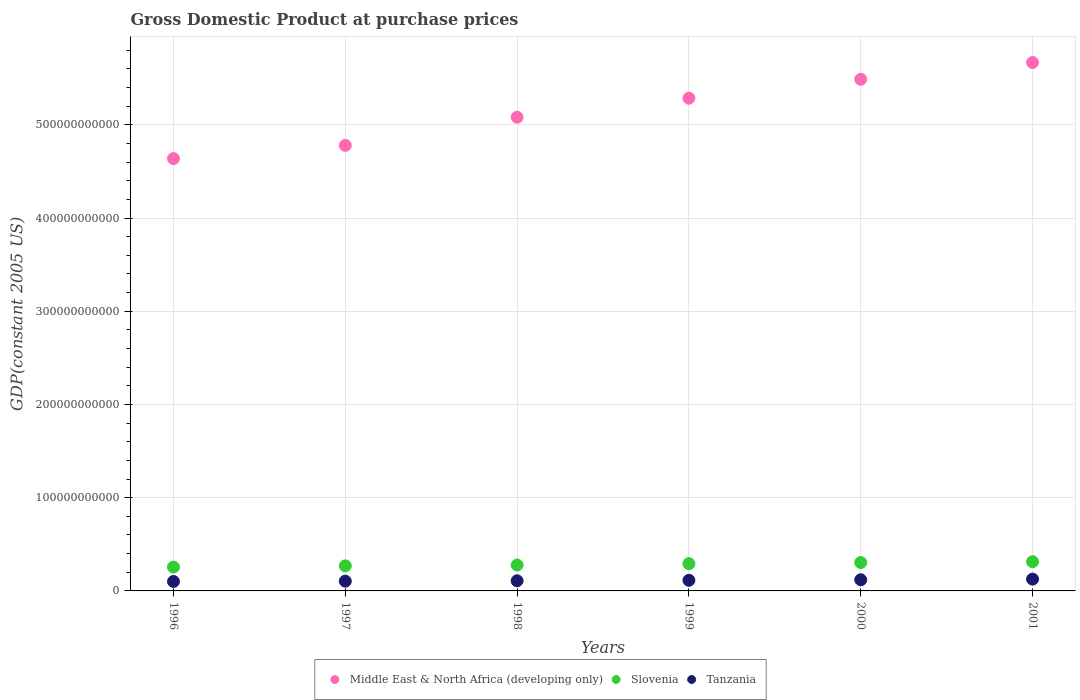How many different coloured dotlines are there?
Keep it short and to the point. 3. Is the number of dotlines equal to the number of legend labels?
Provide a short and direct response. Yes. What is the GDP at purchase prices in Middle East & North Africa (developing only) in 1998?
Your answer should be very brief. 5.08e+11. Across all years, what is the maximum GDP at purchase prices in Slovenia?
Provide a succinct answer. 3.14e+1. Across all years, what is the minimum GDP at purchase prices in Slovenia?
Make the answer very short. 2.56e+1. In which year was the GDP at purchase prices in Tanzania minimum?
Your answer should be very brief. 1996. What is the total GDP at purchase prices in Middle East & North Africa (developing only) in the graph?
Provide a succinct answer. 3.09e+12. What is the difference between the GDP at purchase prices in Slovenia in 1999 and that in 2000?
Provide a succinct answer. -1.22e+09. What is the difference between the GDP at purchase prices in Slovenia in 1997 and the GDP at purchase prices in Tanzania in 2000?
Your response must be concise. 1.49e+1. What is the average GDP at purchase prices in Tanzania per year?
Your response must be concise. 1.12e+1. In the year 2001, what is the difference between the GDP at purchase prices in Slovenia and GDP at purchase prices in Middle East & North Africa (developing only)?
Offer a terse response. -5.36e+11. In how many years, is the GDP at purchase prices in Tanzania greater than 300000000000 US$?
Ensure brevity in your answer.  0. What is the ratio of the GDP at purchase prices in Middle East & North Africa (developing only) in 1996 to that in 1999?
Offer a very short reply. 0.88. Is the GDP at purchase prices in Middle East & North Africa (developing only) in 1996 less than that in 2001?
Give a very brief answer. Yes. What is the difference between the highest and the second highest GDP at purchase prices in Slovenia?
Provide a succinct answer. 8.98e+08. What is the difference between the highest and the lowest GDP at purchase prices in Slovenia?
Your answer should be very brief. 5.77e+09. In how many years, is the GDP at purchase prices in Tanzania greater than the average GDP at purchase prices in Tanzania taken over all years?
Provide a succinct answer. 3. Is the sum of the GDP at purchase prices in Middle East & North Africa (developing only) in 1998 and 1999 greater than the maximum GDP at purchase prices in Slovenia across all years?
Offer a terse response. Yes. Is it the case that in every year, the sum of the GDP at purchase prices in Tanzania and GDP at purchase prices in Slovenia  is greater than the GDP at purchase prices in Middle East & North Africa (developing only)?
Provide a short and direct response. No. Is the GDP at purchase prices in Slovenia strictly greater than the GDP at purchase prices in Middle East & North Africa (developing only) over the years?
Your answer should be compact. No. How many dotlines are there?
Offer a terse response. 3. What is the difference between two consecutive major ticks on the Y-axis?
Keep it short and to the point. 1.00e+11. Does the graph contain any zero values?
Provide a succinct answer. No. Where does the legend appear in the graph?
Ensure brevity in your answer.  Bottom center. How many legend labels are there?
Your answer should be compact. 3. How are the legend labels stacked?
Your answer should be compact. Horizontal. What is the title of the graph?
Provide a short and direct response. Gross Domestic Product at purchase prices. What is the label or title of the Y-axis?
Offer a very short reply. GDP(constant 2005 US). What is the GDP(constant 2005 US) of Middle East & North Africa (developing only) in 1996?
Make the answer very short. 4.64e+11. What is the GDP(constant 2005 US) of Slovenia in 1996?
Make the answer very short. 2.56e+1. What is the GDP(constant 2005 US) of Tanzania in 1996?
Make the answer very short. 1.01e+1. What is the GDP(constant 2005 US) in Middle East & North Africa (developing only) in 1997?
Your response must be concise. 4.78e+11. What is the GDP(constant 2005 US) in Slovenia in 1997?
Provide a succinct answer. 2.69e+1. What is the GDP(constant 2005 US) in Tanzania in 1997?
Make the answer very short. 1.05e+1. What is the GDP(constant 2005 US) in Middle East & North Africa (developing only) in 1998?
Offer a terse response. 5.08e+11. What is the GDP(constant 2005 US) of Slovenia in 1998?
Ensure brevity in your answer.  2.78e+1. What is the GDP(constant 2005 US) of Tanzania in 1998?
Your response must be concise. 1.09e+1. What is the GDP(constant 2005 US) of Middle East & North Africa (developing only) in 1999?
Ensure brevity in your answer.  5.29e+11. What is the GDP(constant 2005 US) in Slovenia in 1999?
Ensure brevity in your answer.  2.92e+1. What is the GDP(constant 2005 US) in Tanzania in 1999?
Offer a terse response. 1.14e+1. What is the GDP(constant 2005 US) in Middle East & North Africa (developing only) in 2000?
Provide a short and direct response. 5.49e+11. What is the GDP(constant 2005 US) of Slovenia in 2000?
Provide a short and direct response. 3.05e+1. What is the GDP(constant 2005 US) in Tanzania in 2000?
Your response must be concise. 1.20e+1. What is the GDP(constant 2005 US) in Middle East & North Africa (developing only) in 2001?
Your answer should be very brief. 5.67e+11. What is the GDP(constant 2005 US) of Slovenia in 2001?
Offer a very short reply. 3.14e+1. What is the GDP(constant 2005 US) of Tanzania in 2001?
Give a very brief answer. 1.27e+1. Across all years, what is the maximum GDP(constant 2005 US) of Middle East & North Africa (developing only)?
Ensure brevity in your answer.  5.67e+11. Across all years, what is the maximum GDP(constant 2005 US) of Slovenia?
Offer a very short reply. 3.14e+1. Across all years, what is the maximum GDP(constant 2005 US) in Tanzania?
Offer a terse response. 1.27e+1. Across all years, what is the minimum GDP(constant 2005 US) in Middle East & North Africa (developing only)?
Your response must be concise. 4.64e+11. Across all years, what is the minimum GDP(constant 2005 US) of Slovenia?
Provide a short and direct response. 2.56e+1. Across all years, what is the minimum GDP(constant 2005 US) of Tanzania?
Keep it short and to the point. 1.01e+1. What is the total GDP(constant 2005 US) in Middle East & North Africa (developing only) in the graph?
Ensure brevity in your answer.  3.09e+12. What is the total GDP(constant 2005 US) in Slovenia in the graph?
Offer a terse response. 1.71e+11. What is the total GDP(constant 2005 US) of Tanzania in the graph?
Provide a short and direct response. 6.75e+1. What is the difference between the GDP(constant 2005 US) of Middle East & North Africa (developing only) in 1996 and that in 1997?
Offer a terse response. -1.42e+1. What is the difference between the GDP(constant 2005 US) of Slovenia in 1996 and that in 1997?
Ensure brevity in your answer.  -1.31e+09. What is the difference between the GDP(constant 2005 US) of Tanzania in 1996 and that in 1997?
Your answer should be very brief. -3.57e+08. What is the difference between the GDP(constant 2005 US) of Middle East & North Africa (developing only) in 1996 and that in 1998?
Your response must be concise. -4.43e+1. What is the difference between the GDP(constant 2005 US) of Slovenia in 1996 and that in 1998?
Give a very brief answer. -2.19e+09. What is the difference between the GDP(constant 2005 US) in Tanzania in 1996 and that in 1998?
Provide a short and direct response. -7.45e+08. What is the difference between the GDP(constant 2005 US) in Middle East & North Africa (developing only) in 1996 and that in 1999?
Offer a terse response. -6.48e+1. What is the difference between the GDP(constant 2005 US) in Slovenia in 1996 and that in 1999?
Your answer should be very brief. -3.66e+09. What is the difference between the GDP(constant 2005 US) in Tanzania in 1996 and that in 1999?
Make the answer very short. -1.27e+09. What is the difference between the GDP(constant 2005 US) of Middle East & North Africa (developing only) in 1996 and that in 2000?
Ensure brevity in your answer.  -8.51e+1. What is the difference between the GDP(constant 2005 US) in Slovenia in 1996 and that in 2000?
Offer a very short reply. -4.87e+09. What is the difference between the GDP(constant 2005 US) in Tanzania in 1996 and that in 2000?
Your answer should be very brief. -1.83e+09. What is the difference between the GDP(constant 2005 US) of Middle East & North Africa (developing only) in 1996 and that in 2001?
Provide a succinct answer. -1.03e+11. What is the difference between the GDP(constant 2005 US) in Slovenia in 1996 and that in 2001?
Offer a very short reply. -5.77e+09. What is the difference between the GDP(constant 2005 US) in Tanzania in 1996 and that in 2001?
Offer a very short reply. -2.55e+09. What is the difference between the GDP(constant 2005 US) of Middle East & North Africa (developing only) in 1997 and that in 1998?
Keep it short and to the point. -3.02e+1. What is the difference between the GDP(constant 2005 US) of Slovenia in 1997 and that in 1998?
Keep it short and to the point. -8.84e+08. What is the difference between the GDP(constant 2005 US) in Tanzania in 1997 and that in 1998?
Provide a succinct answer. -3.89e+08. What is the difference between the GDP(constant 2005 US) of Middle East & North Africa (developing only) in 1997 and that in 1999?
Provide a short and direct response. -5.06e+1. What is the difference between the GDP(constant 2005 US) in Slovenia in 1997 and that in 1999?
Keep it short and to the point. -2.35e+09. What is the difference between the GDP(constant 2005 US) of Tanzania in 1997 and that in 1999?
Provide a short and direct response. -9.15e+08. What is the difference between the GDP(constant 2005 US) in Middle East & North Africa (developing only) in 1997 and that in 2000?
Give a very brief answer. -7.09e+1. What is the difference between the GDP(constant 2005 US) of Slovenia in 1997 and that in 2000?
Provide a short and direct response. -3.56e+09. What is the difference between the GDP(constant 2005 US) in Tanzania in 1997 and that in 2000?
Your response must be concise. -1.48e+09. What is the difference between the GDP(constant 2005 US) of Middle East & North Africa (developing only) in 1997 and that in 2001?
Ensure brevity in your answer.  -8.89e+1. What is the difference between the GDP(constant 2005 US) of Slovenia in 1997 and that in 2001?
Ensure brevity in your answer.  -4.46e+09. What is the difference between the GDP(constant 2005 US) of Tanzania in 1997 and that in 2001?
Keep it short and to the point. -2.19e+09. What is the difference between the GDP(constant 2005 US) of Middle East & North Africa (developing only) in 1998 and that in 1999?
Make the answer very short. -2.04e+1. What is the difference between the GDP(constant 2005 US) in Slovenia in 1998 and that in 1999?
Offer a terse response. -1.47e+09. What is the difference between the GDP(constant 2005 US) of Tanzania in 1998 and that in 1999?
Offer a terse response. -5.26e+08. What is the difference between the GDP(constant 2005 US) of Middle East & North Africa (developing only) in 1998 and that in 2000?
Give a very brief answer. -4.07e+1. What is the difference between the GDP(constant 2005 US) in Slovenia in 1998 and that in 2000?
Offer a very short reply. -2.68e+09. What is the difference between the GDP(constant 2005 US) of Tanzania in 1998 and that in 2000?
Offer a terse response. -1.09e+09. What is the difference between the GDP(constant 2005 US) in Middle East & North Africa (developing only) in 1998 and that in 2001?
Make the answer very short. -5.87e+1. What is the difference between the GDP(constant 2005 US) in Slovenia in 1998 and that in 2001?
Your answer should be very brief. -3.58e+09. What is the difference between the GDP(constant 2005 US) in Tanzania in 1998 and that in 2001?
Your answer should be compact. -1.81e+09. What is the difference between the GDP(constant 2005 US) of Middle East & North Africa (developing only) in 1999 and that in 2000?
Keep it short and to the point. -2.03e+1. What is the difference between the GDP(constant 2005 US) in Slovenia in 1999 and that in 2000?
Your response must be concise. -1.22e+09. What is the difference between the GDP(constant 2005 US) in Tanzania in 1999 and that in 2000?
Ensure brevity in your answer.  -5.62e+08. What is the difference between the GDP(constant 2005 US) in Middle East & North Africa (developing only) in 1999 and that in 2001?
Keep it short and to the point. -3.83e+1. What is the difference between the GDP(constant 2005 US) in Slovenia in 1999 and that in 2001?
Your answer should be very brief. -2.11e+09. What is the difference between the GDP(constant 2005 US) in Tanzania in 1999 and that in 2001?
Your answer should be very brief. -1.28e+09. What is the difference between the GDP(constant 2005 US) of Middle East & North Africa (developing only) in 2000 and that in 2001?
Offer a terse response. -1.80e+1. What is the difference between the GDP(constant 2005 US) in Slovenia in 2000 and that in 2001?
Keep it short and to the point. -8.98e+08. What is the difference between the GDP(constant 2005 US) in Tanzania in 2000 and that in 2001?
Provide a succinct answer. -7.17e+08. What is the difference between the GDP(constant 2005 US) in Middle East & North Africa (developing only) in 1996 and the GDP(constant 2005 US) in Slovenia in 1997?
Give a very brief answer. 4.37e+11. What is the difference between the GDP(constant 2005 US) of Middle East & North Africa (developing only) in 1996 and the GDP(constant 2005 US) of Tanzania in 1997?
Your response must be concise. 4.53e+11. What is the difference between the GDP(constant 2005 US) of Slovenia in 1996 and the GDP(constant 2005 US) of Tanzania in 1997?
Your answer should be very brief. 1.51e+1. What is the difference between the GDP(constant 2005 US) of Middle East & North Africa (developing only) in 1996 and the GDP(constant 2005 US) of Slovenia in 1998?
Ensure brevity in your answer.  4.36e+11. What is the difference between the GDP(constant 2005 US) in Middle East & North Africa (developing only) in 1996 and the GDP(constant 2005 US) in Tanzania in 1998?
Provide a short and direct response. 4.53e+11. What is the difference between the GDP(constant 2005 US) in Slovenia in 1996 and the GDP(constant 2005 US) in Tanzania in 1998?
Your response must be concise. 1.47e+1. What is the difference between the GDP(constant 2005 US) in Middle East & North Africa (developing only) in 1996 and the GDP(constant 2005 US) in Slovenia in 1999?
Provide a succinct answer. 4.35e+11. What is the difference between the GDP(constant 2005 US) of Middle East & North Africa (developing only) in 1996 and the GDP(constant 2005 US) of Tanzania in 1999?
Offer a terse response. 4.52e+11. What is the difference between the GDP(constant 2005 US) in Slovenia in 1996 and the GDP(constant 2005 US) in Tanzania in 1999?
Offer a very short reply. 1.42e+1. What is the difference between the GDP(constant 2005 US) in Middle East & North Africa (developing only) in 1996 and the GDP(constant 2005 US) in Slovenia in 2000?
Make the answer very short. 4.33e+11. What is the difference between the GDP(constant 2005 US) of Middle East & North Africa (developing only) in 1996 and the GDP(constant 2005 US) of Tanzania in 2000?
Offer a very short reply. 4.52e+11. What is the difference between the GDP(constant 2005 US) of Slovenia in 1996 and the GDP(constant 2005 US) of Tanzania in 2000?
Provide a short and direct response. 1.36e+1. What is the difference between the GDP(constant 2005 US) in Middle East & North Africa (developing only) in 1996 and the GDP(constant 2005 US) in Slovenia in 2001?
Keep it short and to the point. 4.32e+11. What is the difference between the GDP(constant 2005 US) of Middle East & North Africa (developing only) in 1996 and the GDP(constant 2005 US) of Tanzania in 2001?
Ensure brevity in your answer.  4.51e+11. What is the difference between the GDP(constant 2005 US) in Slovenia in 1996 and the GDP(constant 2005 US) in Tanzania in 2001?
Make the answer very short. 1.29e+1. What is the difference between the GDP(constant 2005 US) of Middle East & North Africa (developing only) in 1997 and the GDP(constant 2005 US) of Slovenia in 1998?
Give a very brief answer. 4.50e+11. What is the difference between the GDP(constant 2005 US) of Middle East & North Africa (developing only) in 1997 and the GDP(constant 2005 US) of Tanzania in 1998?
Offer a terse response. 4.67e+11. What is the difference between the GDP(constant 2005 US) of Slovenia in 1997 and the GDP(constant 2005 US) of Tanzania in 1998?
Keep it short and to the point. 1.60e+1. What is the difference between the GDP(constant 2005 US) in Middle East & North Africa (developing only) in 1997 and the GDP(constant 2005 US) in Slovenia in 1999?
Offer a very short reply. 4.49e+11. What is the difference between the GDP(constant 2005 US) in Middle East & North Africa (developing only) in 1997 and the GDP(constant 2005 US) in Tanzania in 1999?
Your answer should be compact. 4.67e+11. What is the difference between the GDP(constant 2005 US) in Slovenia in 1997 and the GDP(constant 2005 US) in Tanzania in 1999?
Provide a succinct answer. 1.55e+1. What is the difference between the GDP(constant 2005 US) in Middle East & North Africa (developing only) in 1997 and the GDP(constant 2005 US) in Slovenia in 2000?
Your answer should be compact. 4.48e+11. What is the difference between the GDP(constant 2005 US) in Middle East & North Africa (developing only) in 1997 and the GDP(constant 2005 US) in Tanzania in 2000?
Provide a succinct answer. 4.66e+11. What is the difference between the GDP(constant 2005 US) of Slovenia in 1997 and the GDP(constant 2005 US) of Tanzania in 2000?
Keep it short and to the point. 1.49e+1. What is the difference between the GDP(constant 2005 US) of Middle East & North Africa (developing only) in 1997 and the GDP(constant 2005 US) of Slovenia in 2001?
Your answer should be compact. 4.47e+11. What is the difference between the GDP(constant 2005 US) in Middle East & North Africa (developing only) in 1997 and the GDP(constant 2005 US) in Tanzania in 2001?
Give a very brief answer. 4.65e+11. What is the difference between the GDP(constant 2005 US) in Slovenia in 1997 and the GDP(constant 2005 US) in Tanzania in 2001?
Your answer should be very brief. 1.42e+1. What is the difference between the GDP(constant 2005 US) in Middle East & North Africa (developing only) in 1998 and the GDP(constant 2005 US) in Slovenia in 1999?
Make the answer very short. 4.79e+11. What is the difference between the GDP(constant 2005 US) of Middle East & North Africa (developing only) in 1998 and the GDP(constant 2005 US) of Tanzania in 1999?
Your answer should be very brief. 4.97e+11. What is the difference between the GDP(constant 2005 US) in Slovenia in 1998 and the GDP(constant 2005 US) in Tanzania in 1999?
Offer a very short reply. 1.64e+1. What is the difference between the GDP(constant 2005 US) of Middle East & North Africa (developing only) in 1998 and the GDP(constant 2005 US) of Slovenia in 2000?
Provide a short and direct response. 4.78e+11. What is the difference between the GDP(constant 2005 US) of Middle East & North Africa (developing only) in 1998 and the GDP(constant 2005 US) of Tanzania in 2000?
Your response must be concise. 4.96e+11. What is the difference between the GDP(constant 2005 US) in Slovenia in 1998 and the GDP(constant 2005 US) in Tanzania in 2000?
Your answer should be very brief. 1.58e+1. What is the difference between the GDP(constant 2005 US) in Middle East & North Africa (developing only) in 1998 and the GDP(constant 2005 US) in Slovenia in 2001?
Provide a short and direct response. 4.77e+11. What is the difference between the GDP(constant 2005 US) in Middle East & North Africa (developing only) in 1998 and the GDP(constant 2005 US) in Tanzania in 2001?
Provide a short and direct response. 4.95e+11. What is the difference between the GDP(constant 2005 US) of Slovenia in 1998 and the GDP(constant 2005 US) of Tanzania in 2001?
Offer a terse response. 1.51e+1. What is the difference between the GDP(constant 2005 US) of Middle East & North Africa (developing only) in 1999 and the GDP(constant 2005 US) of Slovenia in 2000?
Your answer should be compact. 4.98e+11. What is the difference between the GDP(constant 2005 US) in Middle East & North Africa (developing only) in 1999 and the GDP(constant 2005 US) in Tanzania in 2000?
Keep it short and to the point. 5.17e+11. What is the difference between the GDP(constant 2005 US) of Slovenia in 1999 and the GDP(constant 2005 US) of Tanzania in 2000?
Your answer should be compact. 1.73e+1. What is the difference between the GDP(constant 2005 US) in Middle East & North Africa (developing only) in 1999 and the GDP(constant 2005 US) in Slovenia in 2001?
Offer a very short reply. 4.97e+11. What is the difference between the GDP(constant 2005 US) of Middle East & North Africa (developing only) in 1999 and the GDP(constant 2005 US) of Tanzania in 2001?
Your response must be concise. 5.16e+11. What is the difference between the GDP(constant 2005 US) of Slovenia in 1999 and the GDP(constant 2005 US) of Tanzania in 2001?
Provide a short and direct response. 1.66e+1. What is the difference between the GDP(constant 2005 US) of Middle East & North Africa (developing only) in 2000 and the GDP(constant 2005 US) of Slovenia in 2001?
Your response must be concise. 5.18e+11. What is the difference between the GDP(constant 2005 US) in Middle East & North Africa (developing only) in 2000 and the GDP(constant 2005 US) in Tanzania in 2001?
Offer a terse response. 5.36e+11. What is the difference between the GDP(constant 2005 US) in Slovenia in 2000 and the GDP(constant 2005 US) in Tanzania in 2001?
Offer a very short reply. 1.78e+1. What is the average GDP(constant 2005 US) in Middle East & North Africa (developing only) per year?
Ensure brevity in your answer.  5.16e+11. What is the average GDP(constant 2005 US) in Slovenia per year?
Offer a terse response. 2.86e+1. What is the average GDP(constant 2005 US) in Tanzania per year?
Your answer should be compact. 1.12e+1. In the year 1996, what is the difference between the GDP(constant 2005 US) in Middle East & North Africa (developing only) and GDP(constant 2005 US) in Slovenia?
Provide a succinct answer. 4.38e+11. In the year 1996, what is the difference between the GDP(constant 2005 US) of Middle East & North Africa (developing only) and GDP(constant 2005 US) of Tanzania?
Make the answer very short. 4.54e+11. In the year 1996, what is the difference between the GDP(constant 2005 US) in Slovenia and GDP(constant 2005 US) in Tanzania?
Give a very brief answer. 1.55e+1. In the year 1997, what is the difference between the GDP(constant 2005 US) in Middle East & North Africa (developing only) and GDP(constant 2005 US) in Slovenia?
Keep it short and to the point. 4.51e+11. In the year 1997, what is the difference between the GDP(constant 2005 US) of Middle East & North Africa (developing only) and GDP(constant 2005 US) of Tanzania?
Provide a short and direct response. 4.68e+11. In the year 1997, what is the difference between the GDP(constant 2005 US) of Slovenia and GDP(constant 2005 US) of Tanzania?
Give a very brief answer. 1.64e+1. In the year 1998, what is the difference between the GDP(constant 2005 US) of Middle East & North Africa (developing only) and GDP(constant 2005 US) of Slovenia?
Your answer should be compact. 4.80e+11. In the year 1998, what is the difference between the GDP(constant 2005 US) in Middle East & North Africa (developing only) and GDP(constant 2005 US) in Tanzania?
Your response must be concise. 4.97e+11. In the year 1998, what is the difference between the GDP(constant 2005 US) in Slovenia and GDP(constant 2005 US) in Tanzania?
Ensure brevity in your answer.  1.69e+1. In the year 1999, what is the difference between the GDP(constant 2005 US) in Middle East & North Africa (developing only) and GDP(constant 2005 US) in Slovenia?
Offer a very short reply. 4.99e+11. In the year 1999, what is the difference between the GDP(constant 2005 US) of Middle East & North Africa (developing only) and GDP(constant 2005 US) of Tanzania?
Your answer should be very brief. 5.17e+11. In the year 1999, what is the difference between the GDP(constant 2005 US) of Slovenia and GDP(constant 2005 US) of Tanzania?
Offer a very short reply. 1.79e+1. In the year 2000, what is the difference between the GDP(constant 2005 US) of Middle East & North Africa (developing only) and GDP(constant 2005 US) of Slovenia?
Provide a short and direct response. 5.18e+11. In the year 2000, what is the difference between the GDP(constant 2005 US) of Middle East & North Africa (developing only) and GDP(constant 2005 US) of Tanzania?
Your response must be concise. 5.37e+11. In the year 2000, what is the difference between the GDP(constant 2005 US) of Slovenia and GDP(constant 2005 US) of Tanzania?
Offer a terse response. 1.85e+1. In the year 2001, what is the difference between the GDP(constant 2005 US) of Middle East & North Africa (developing only) and GDP(constant 2005 US) of Slovenia?
Your response must be concise. 5.36e+11. In the year 2001, what is the difference between the GDP(constant 2005 US) of Middle East & North Africa (developing only) and GDP(constant 2005 US) of Tanzania?
Provide a succinct answer. 5.54e+11. In the year 2001, what is the difference between the GDP(constant 2005 US) of Slovenia and GDP(constant 2005 US) of Tanzania?
Make the answer very short. 1.87e+1. What is the ratio of the GDP(constant 2005 US) of Middle East & North Africa (developing only) in 1996 to that in 1997?
Make the answer very short. 0.97. What is the ratio of the GDP(constant 2005 US) in Slovenia in 1996 to that in 1997?
Your answer should be compact. 0.95. What is the ratio of the GDP(constant 2005 US) in Tanzania in 1996 to that in 1997?
Your answer should be very brief. 0.97. What is the ratio of the GDP(constant 2005 US) of Middle East & North Africa (developing only) in 1996 to that in 1998?
Offer a terse response. 0.91. What is the ratio of the GDP(constant 2005 US) of Slovenia in 1996 to that in 1998?
Ensure brevity in your answer.  0.92. What is the ratio of the GDP(constant 2005 US) of Tanzania in 1996 to that in 1998?
Offer a very short reply. 0.93. What is the ratio of the GDP(constant 2005 US) in Middle East & North Africa (developing only) in 1996 to that in 1999?
Your answer should be compact. 0.88. What is the ratio of the GDP(constant 2005 US) in Slovenia in 1996 to that in 1999?
Provide a succinct answer. 0.87. What is the ratio of the GDP(constant 2005 US) in Tanzania in 1996 to that in 1999?
Provide a short and direct response. 0.89. What is the ratio of the GDP(constant 2005 US) of Middle East & North Africa (developing only) in 1996 to that in 2000?
Your answer should be compact. 0.84. What is the ratio of the GDP(constant 2005 US) of Slovenia in 1996 to that in 2000?
Give a very brief answer. 0.84. What is the ratio of the GDP(constant 2005 US) in Tanzania in 1996 to that in 2000?
Provide a succinct answer. 0.85. What is the ratio of the GDP(constant 2005 US) of Middle East & North Africa (developing only) in 1996 to that in 2001?
Give a very brief answer. 0.82. What is the ratio of the GDP(constant 2005 US) in Slovenia in 1996 to that in 2001?
Offer a very short reply. 0.82. What is the ratio of the GDP(constant 2005 US) of Tanzania in 1996 to that in 2001?
Your answer should be compact. 0.8. What is the ratio of the GDP(constant 2005 US) of Middle East & North Africa (developing only) in 1997 to that in 1998?
Offer a terse response. 0.94. What is the ratio of the GDP(constant 2005 US) of Slovenia in 1997 to that in 1998?
Offer a very short reply. 0.97. What is the ratio of the GDP(constant 2005 US) of Tanzania in 1997 to that in 1998?
Your answer should be compact. 0.96. What is the ratio of the GDP(constant 2005 US) in Middle East & North Africa (developing only) in 1997 to that in 1999?
Keep it short and to the point. 0.9. What is the ratio of the GDP(constant 2005 US) of Slovenia in 1997 to that in 1999?
Your response must be concise. 0.92. What is the ratio of the GDP(constant 2005 US) of Tanzania in 1997 to that in 1999?
Provide a succinct answer. 0.92. What is the ratio of the GDP(constant 2005 US) of Middle East & North Africa (developing only) in 1997 to that in 2000?
Make the answer very short. 0.87. What is the ratio of the GDP(constant 2005 US) in Slovenia in 1997 to that in 2000?
Keep it short and to the point. 0.88. What is the ratio of the GDP(constant 2005 US) in Tanzania in 1997 to that in 2000?
Ensure brevity in your answer.  0.88. What is the ratio of the GDP(constant 2005 US) of Middle East & North Africa (developing only) in 1997 to that in 2001?
Provide a short and direct response. 0.84. What is the ratio of the GDP(constant 2005 US) in Slovenia in 1997 to that in 2001?
Make the answer very short. 0.86. What is the ratio of the GDP(constant 2005 US) of Tanzania in 1997 to that in 2001?
Give a very brief answer. 0.83. What is the ratio of the GDP(constant 2005 US) in Middle East & North Africa (developing only) in 1998 to that in 1999?
Make the answer very short. 0.96. What is the ratio of the GDP(constant 2005 US) of Slovenia in 1998 to that in 1999?
Your answer should be compact. 0.95. What is the ratio of the GDP(constant 2005 US) of Tanzania in 1998 to that in 1999?
Your answer should be compact. 0.95. What is the ratio of the GDP(constant 2005 US) in Middle East & North Africa (developing only) in 1998 to that in 2000?
Your response must be concise. 0.93. What is the ratio of the GDP(constant 2005 US) in Slovenia in 1998 to that in 2000?
Your answer should be very brief. 0.91. What is the ratio of the GDP(constant 2005 US) in Tanzania in 1998 to that in 2000?
Offer a terse response. 0.91. What is the ratio of the GDP(constant 2005 US) of Middle East & North Africa (developing only) in 1998 to that in 2001?
Offer a very short reply. 0.9. What is the ratio of the GDP(constant 2005 US) of Slovenia in 1998 to that in 2001?
Offer a very short reply. 0.89. What is the ratio of the GDP(constant 2005 US) of Tanzania in 1998 to that in 2001?
Make the answer very short. 0.86. What is the ratio of the GDP(constant 2005 US) in Slovenia in 1999 to that in 2000?
Your answer should be compact. 0.96. What is the ratio of the GDP(constant 2005 US) in Tanzania in 1999 to that in 2000?
Your answer should be very brief. 0.95. What is the ratio of the GDP(constant 2005 US) of Middle East & North Africa (developing only) in 1999 to that in 2001?
Your answer should be compact. 0.93. What is the ratio of the GDP(constant 2005 US) of Slovenia in 1999 to that in 2001?
Offer a very short reply. 0.93. What is the ratio of the GDP(constant 2005 US) of Tanzania in 1999 to that in 2001?
Keep it short and to the point. 0.9. What is the ratio of the GDP(constant 2005 US) of Middle East & North Africa (developing only) in 2000 to that in 2001?
Provide a short and direct response. 0.97. What is the ratio of the GDP(constant 2005 US) in Slovenia in 2000 to that in 2001?
Give a very brief answer. 0.97. What is the ratio of the GDP(constant 2005 US) in Tanzania in 2000 to that in 2001?
Your answer should be compact. 0.94. What is the difference between the highest and the second highest GDP(constant 2005 US) of Middle East & North Africa (developing only)?
Offer a very short reply. 1.80e+1. What is the difference between the highest and the second highest GDP(constant 2005 US) of Slovenia?
Your answer should be very brief. 8.98e+08. What is the difference between the highest and the second highest GDP(constant 2005 US) in Tanzania?
Your answer should be compact. 7.17e+08. What is the difference between the highest and the lowest GDP(constant 2005 US) of Middle East & North Africa (developing only)?
Keep it short and to the point. 1.03e+11. What is the difference between the highest and the lowest GDP(constant 2005 US) of Slovenia?
Your response must be concise. 5.77e+09. What is the difference between the highest and the lowest GDP(constant 2005 US) in Tanzania?
Offer a terse response. 2.55e+09. 